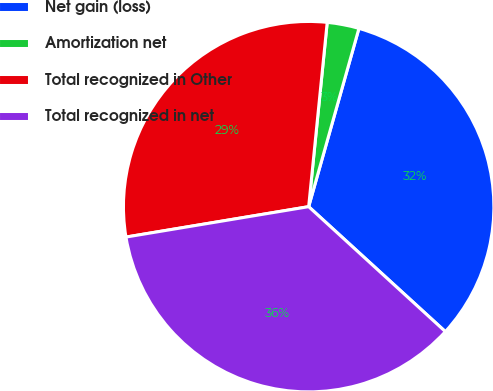Convert chart to OTSL. <chart><loc_0><loc_0><loc_500><loc_500><pie_chart><fcel>Net gain (loss)<fcel>Amortization net<fcel>Total recognized in Other<fcel>Total recognized in net<nl><fcel>32.41%<fcel>2.78%<fcel>29.22%<fcel>35.59%<nl></chart> 